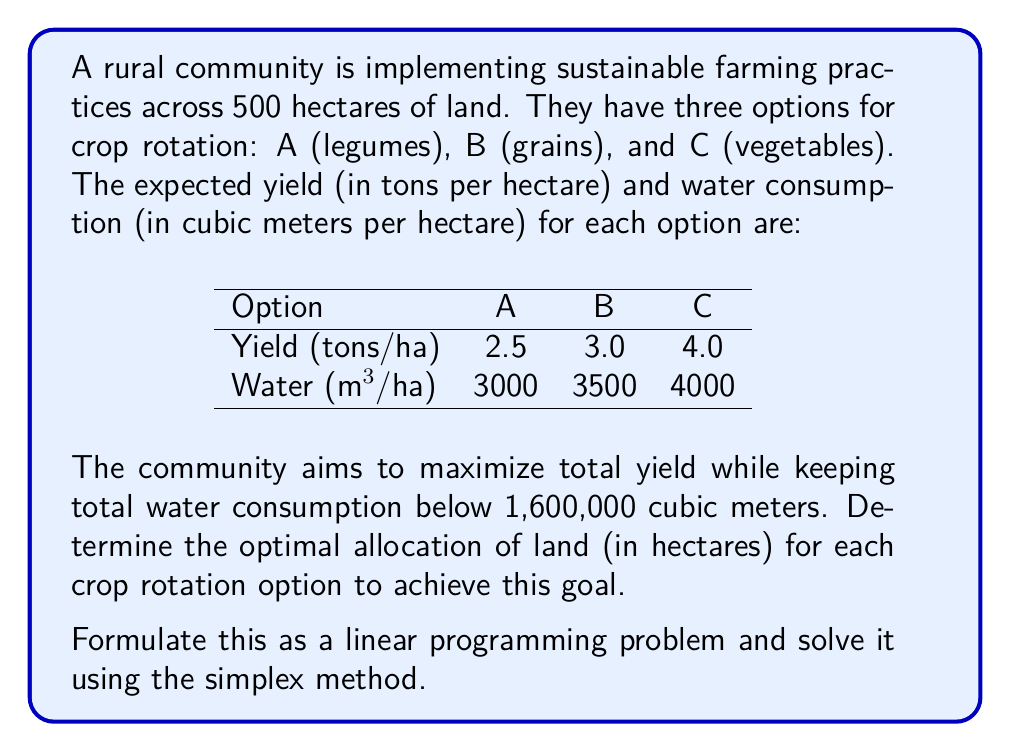Teach me how to tackle this problem. Let's approach this step-by-step:

1) Define variables:
   Let $x_A$, $x_B$, and $x_C$ be the number of hectares allocated to options A, B, and C respectively.

2) Formulate the objective function:
   Maximize $Z = 2.5x_A + 3.0x_B + 4.0x_C$

3) Identify constraints:
   a) Total land constraint: $x_A + x_B + x_C \leq 500$
   b) Water consumption constraint: $3000x_A + 3500x_B + 4000x_C \leq 1600000$
   c) Non-negativity constraints: $x_A, x_B, x_C \geq 0$

4) Standard form of the LP problem:
   Maximize $Z = 2.5x_A + 3.0x_B + 4.0x_C$
   Subject to:
   $x_A + x_B + x_C + s_1 = 500$
   $3000x_A + 3500x_B + 4000x_C + s_2 = 1600000$
   $x_A, x_B, x_C, s_1, s_2 \geq 0$

   Where $s_1$ and $s_2$ are slack variables.

5) Initial simplex tableau:

   $$
   \begin{array}{c|ccccc|c}
   & x_A & x_B & x_C & s_1 & s_2 & \text{RHS} \\
   \hline
   s_1 & 1 & 1 & 1 & 1 & 0 & 500 \\
   s_2 & 3000 & 3500 & 4000 & 0 & 1 & 1600000 \\
   \hline
   Z & -2.5 & -3.0 & -4.0 & 0 & 0 & 0
   \end{array}
   $$

6) Perform simplex iterations:
   After several iterations, we reach the optimal solution:

   $$
   \begin{array}{c|ccccc|c}
   & x_A & x_B & x_C & s_1 & s_2 & \text{RHS} \\
   \hline
   x_C & 0 & 0 & 1 & 1 & 0 & 400 \\
   x_A & 1 & 0 & 0 & -3 & 1/3000 & 100 \\
   \hline
   Z & 0 & -0.5 & 0 & 1 & 1/750 & 1600
   \end{array}
   $$

7) Interpret the solution:
   $x_A = 100$ hectares
   $x_B = 0$ hectares
   $x_C = 400$ hectares
   Maximum yield = 1600 tons
Answer: The optimal allocation is 100 hectares for crop rotation A (legumes), 0 hectares for B (grains), and 400 hectares for C (vegetables), resulting in a maximum yield of 1600 tons. 